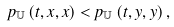Convert formula to latex. <formula><loc_0><loc_0><loc_500><loc_500>p _ { \mathbb { U } } \left ( t , x , x \right ) < p _ { \mathbb { U } } \left ( t , y , y \right ) ,</formula> 